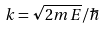Convert formula to latex. <formula><loc_0><loc_0><loc_500><loc_500>k = \sqrt { 2 m E } / \hbar</formula> 